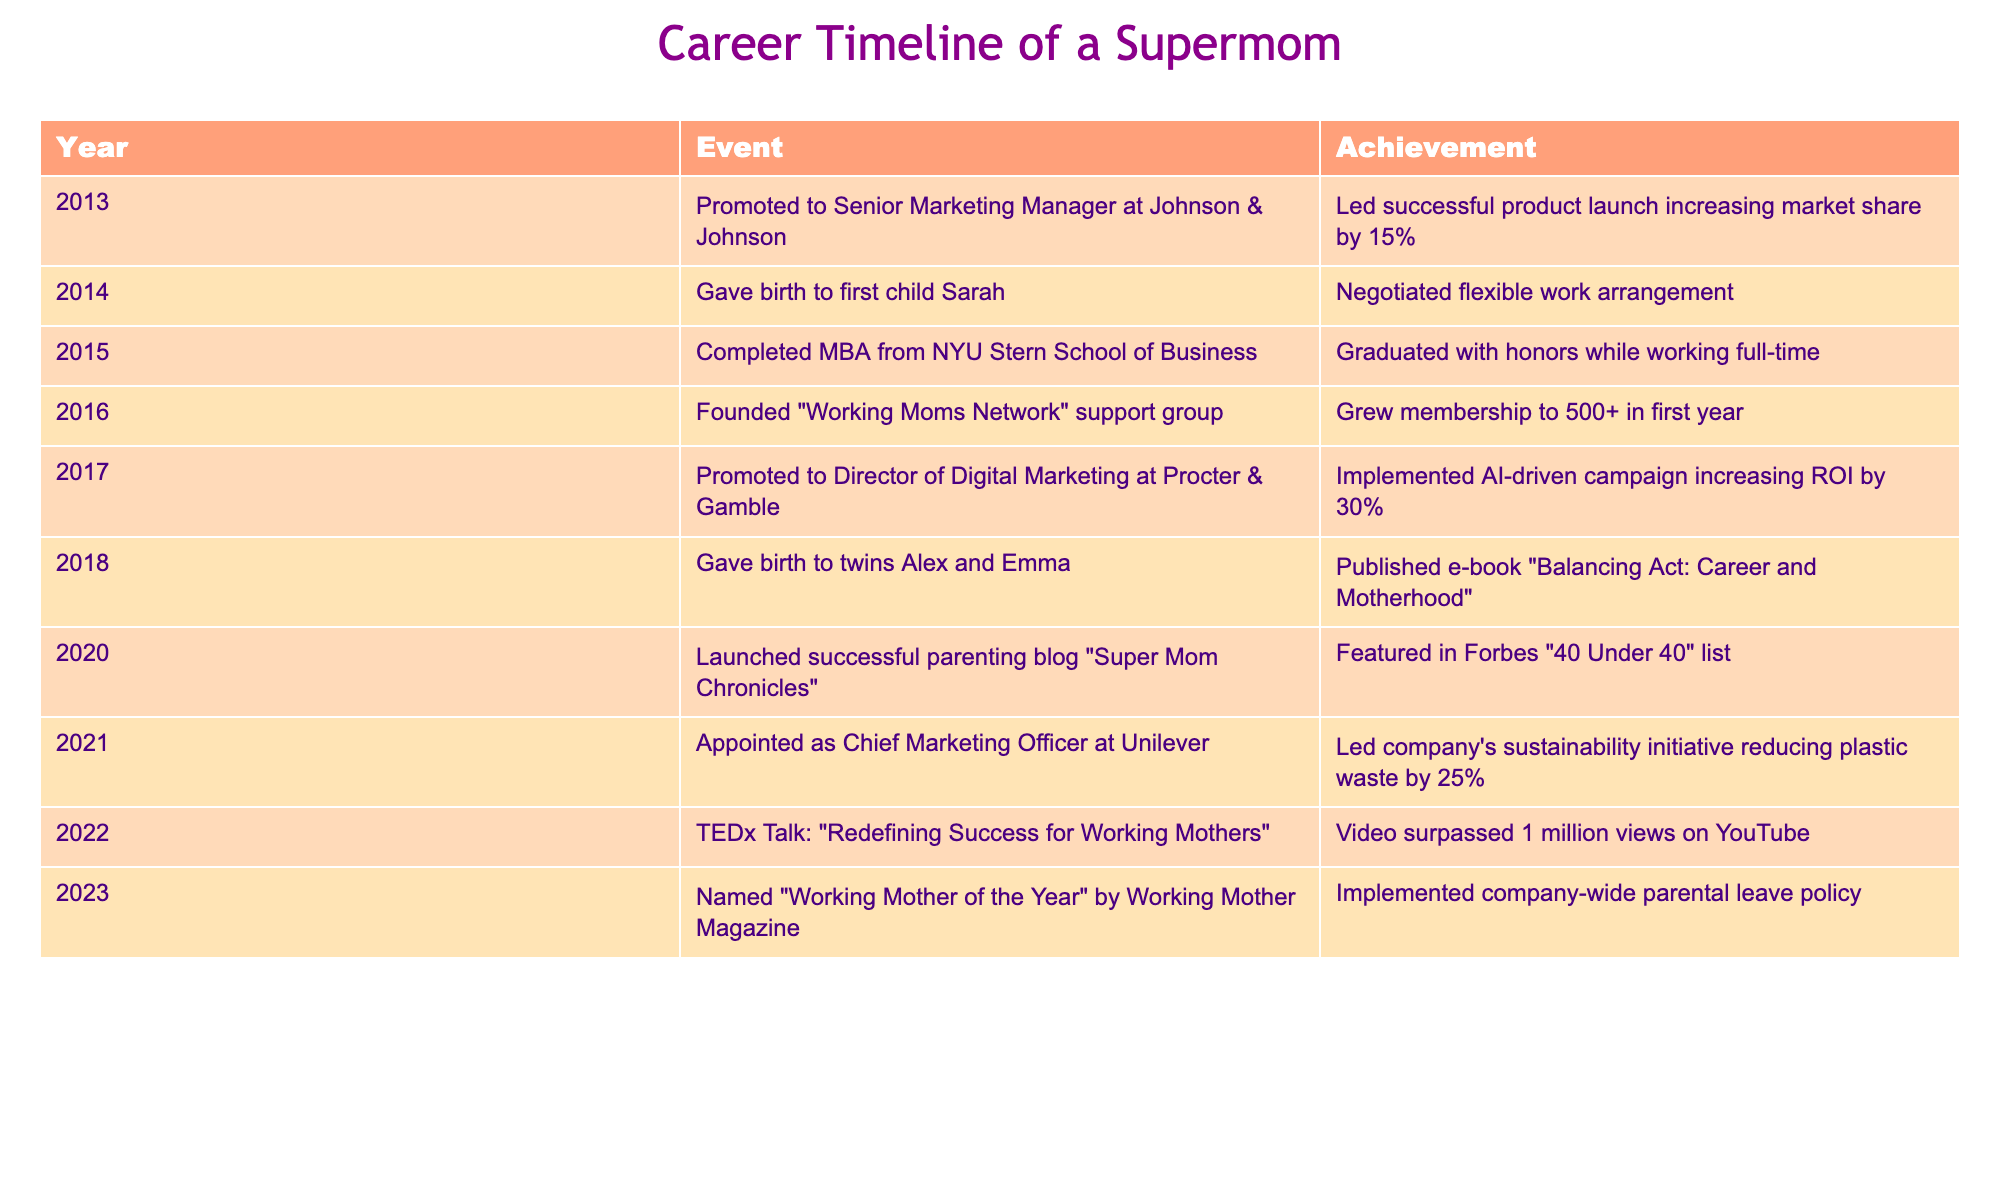What year was the working mom promoted to Director of Digital Marketing? The table shows a timeline of events and achievements. By looking at the "Year" column, I see that she was promoted to Director of Digital Marketing at Procter & Gamble in 2017.
Answer: 2017 How many children did the working mom give birth to in total? The table indicates two separate events for childbirth: one in 2014 (first child Sarah) and another in 2018 for twins (Alex and Emma). Therefore, the total number of children is 1 + 2 = 3.
Answer: 3 What event occurred immediately after completing her MBA from NYU Stern? The table lists events chronologically. After the completion of her MBA in 2015, the next event in the timeline is founding the "Working Moms Network" support group in 2016.
Answer: Founded "Working Moms Network" support group Was she featured in the Forbes "40 Under 40" list before or after she launched the parenting blog? The timeline shows that the parenting blog "Super Mom Chronicles" was launched in 2020, and she was featured in Forbes "40 Under 40" list in the same year. This means both events occurred in 2020, but the feature can be considered to have happened after the blog launch if following a loose chronological order.
Answer: Yes, in the same year What percentage increase in ROI did the working mom's AI-driven campaign achieve? In the event from 2017, it explicitly states that she implemented an AI-driven campaign that increased ROI by 30%.
Answer: 30% What was a significant achievement corresponding to the year 2021? According to the timeline, in 2021, she was appointed as Chief Marketing Officer at Unilever, and she led the company's sustainability initiative reducing plastic waste by 25%.
Answer: Led sustainability initiative reducing plastic waste by 25% How many years passed from her promotion to Senior Marketing Manager to being named "Working Mother of the Year"? The timeline indicates she was promoted to Senior Marketing Manager in 2013 and named "Working Mother of the Year" in 2023. The number of years between these two events is 2023 - 2013 = 10 years.
Answer: 10 years What was her major accomplishment noted in 2022? The event in 2022 highlights that she delivered a TEDx Talk titled "Redefining Success for Working Mothers," which gained significant attention with the video surpassing 1 million views on YouTube.
Answer: Delivered TEDx Talk with 1 million views Which organization did she lead the sustainability initiative with, and what was the specific percentage reduction in plastic waste? The table states she was the Chief Marketing Officer at Unilever in 2021, where she led the sustainability initiative leading to a 25% reduction in plastic waste.
Answer: Unilever, 25% reduction 